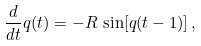<formula> <loc_0><loc_0><loc_500><loc_500>\frac { d } { d t } q ( t ) = - R \, \sin [ q ( t - 1 ) ] \, ,</formula> 